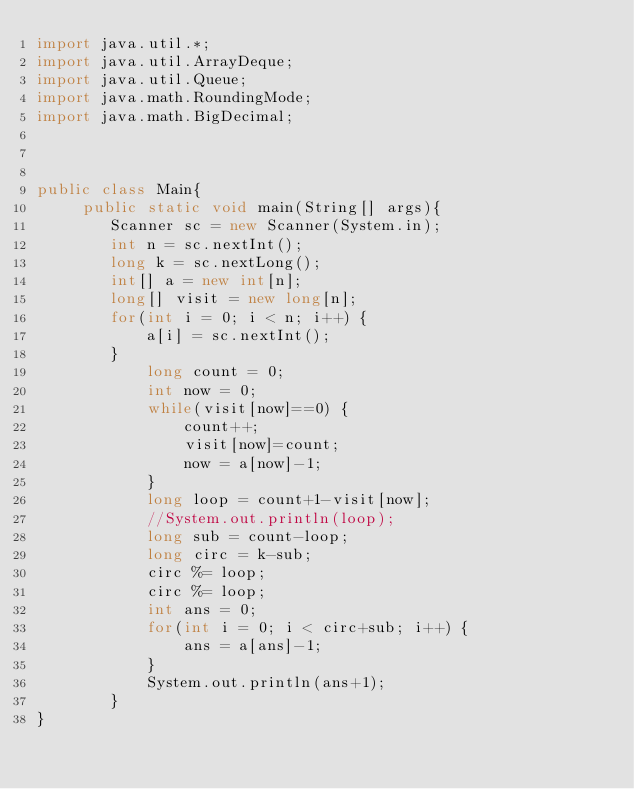<code> <loc_0><loc_0><loc_500><loc_500><_Java_>import java.util.*;
import java.util.ArrayDeque;
import java.util.Queue;
import java.math.RoundingMode;
import java.math.BigDecimal;
 
 
 
public class Main{
	 public static void main(String[] args){
		Scanner sc = new Scanner(System.in);
		int n = sc.nextInt();
		long k = sc.nextLong();
		int[] a = new int[n];
		long[] visit = new long[n];
		for(int i = 0; i < n; i++) {
			a[i] = sc.nextInt();
		}
			long count = 0;
			int now = 0;
			while(visit[now]==0) {
				count++;
				visit[now]=count;
				now = a[now]-1;
			}
			long loop = count+1-visit[now];
			//System.out.println(loop);
			long sub = count-loop;
			long circ = k-sub;
			circ %= loop;
			circ %= loop;
			int ans = 0;
			for(int i = 0; i < circ+sub; i++) {
				ans = a[ans]-1;
			}
			System.out.println(ans+1);
		}
}</code> 